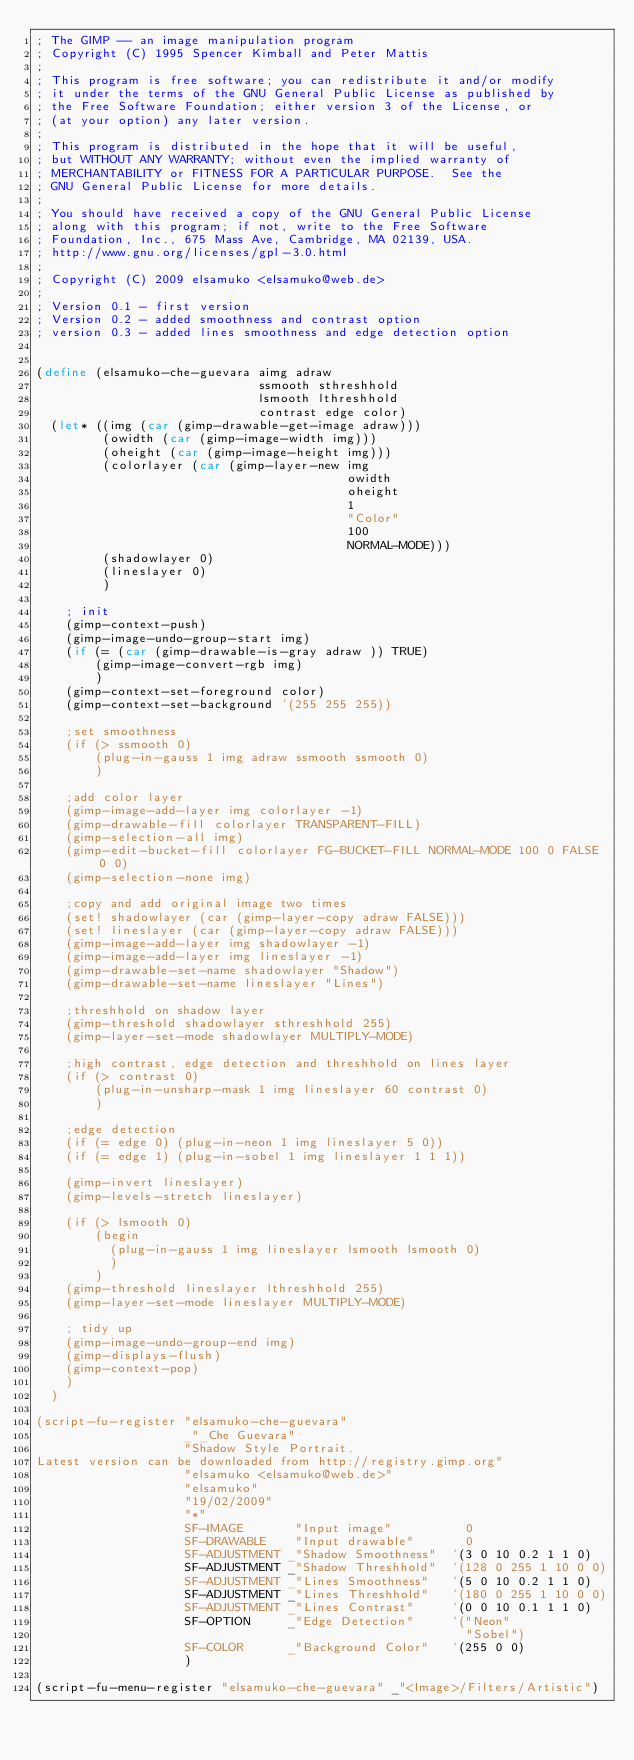<code> <loc_0><loc_0><loc_500><loc_500><_Scheme_>; The GIMP -- an image manipulation program
; Copyright (C) 1995 Spencer Kimball and Peter Mattis
;
; This program is free software; you can redistribute it and/or modify
; it under the terms of the GNU General Public License as published by
; the Free Software Foundation; either version 3 of the License, or
; (at your option) any later version.
; 
; This program is distributed in the hope that it will be useful,
; but WITHOUT ANY WARRANTY; without even the implied warranty of
; MERCHANTABILITY or FITNESS FOR A PARTICULAR PURPOSE.  See the
; GNU General Public License for more details.
; 
; You should have received a copy of the GNU General Public License
; along with this program; if not, write to the Free Software
; Foundation, Inc., 675 Mass Ave, Cambridge, MA 02139, USA.
; http://www.gnu.org/licenses/gpl-3.0.html
;
; Copyright (C) 2009 elsamuko <elsamuko@web.de>
;
; Version 0.1 - first version
; Version 0.2 - added smoothness and contrast option
; version 0.3 - added lines smoothness and edge detection option


(define (elsamuko-che-guevara aimg adraw
                              ssmooth sthreshhold
                              lsmooth lthreshhold
                              contrast edge color)
  (let* ((img (car (gimp-drawable-get-image adraw)))
         (owidth (car (gimp-image-width img)))
         (oheight (car (gimp-image-height img)))
         (colorlayer (car (gimp-layer-new img
                                          owidth 
                                          oheight
                                          1
                                          "Color" 
                                          100 
                                          NORMAL-MODE)))
         (shadowlayer 0)
         (lineslayer 0)
         )
    
    ; init
    (gimp-context-push)
    (gimp-image-undo-group-start img)
    (if (= (car (gimp-drawable-is-gray adraw )) TRUE)
        (gimp-image-convert-rgb img)
        )
    (gimp-context-set-foreground color)
    (gimp-context-set-background '(255 255 255))
    
    ;set smoothness
    (if (> ssmooth 0)
        (plug-in-gauss 1 img adraw ssmooth ssmooth 0)
        )
    
    ;add color layer
    (gimp-image-add-layer img colorlayer -1)
    (gimp-drawable-fill colorlayer TRANSPARENT-FILL)
    (gimp-selection-all img)
    (gimp-edit-bucket-fill colorlayer FG-BUCKET-FILL NORMAL-MODE 100 0 FALSE 0 0)
    (gimp-selection-none img)
    
    ;copy and add original image two times
    (set! shadowlayer (car (gimp-layer-copy adraw FALSE)))
    (set! lineslayer (car (gimp-layer-copy adraw FALSE)))
    (gimp-image-add-layer img shadowlayer -1)
    (gimp-image-add-layer img lineslayer -1)
    (gimp-drawable-set-name shadowlayer "Shadow")
    (gimp-drawable-set-name lineslayer "Lines")
    
    ;threshhold on shadow layer
    (gimp-threshold shadowlayer sthreshhold 255)
    (gimp-layer-set-mode shadowlayer MULTIPLY-MODE)
    
    ;high contrast, edge detection and threshhold on lines layer
    (if (> contrast 0)
        (plug-in-unsharp-mask 1 img lineslayer 60 contrast 0)
        )
    
    ;edge detection
    (if (= edge 0) (plug-in-neon 1 img lineslayer 5 0))
    (if (= edge 1) (plug-in-sobel 1 img lineslayer 1 1 1))

    (gimp-invert lineslayer)
    (gimp-levels-stretch lineslayer)
    
    (if (> lsmooth 0)
        (begin
          (plug-in-gauss 1 img lineslayer lsmooth lsmooth 0)
          )
        )
    (gimp-threshold lineslayer lthreshhold 255)
    (gimp-layer-set-mode lineslayer MULTIPLY-MODE)
    
    ; tidy up
    (gimp-image-undo-group-end img)
    (gimp-displays-flush)
    (gimp-context-pop)
    )
  )

(script-fu-register "elsamuko-che-guevara"
                    _"_Che Guevara"
                    "Shadow Style Portrait.
Latest version can be downloaded from http://registry.gimp.org"
                    "elsamuko <elsamuko@web.de>"
                    "elsamuko"
                    "19/02/2009"
                    "*"
                    SF-IMAGE       "Input image"          0
                    SF-DRAWABLE    "Input drawable"       0
                    SF-ADJUSTMENT _"Shadow Smoothness"  '(3 0 10 0.2 1 1 0)
                    SF-ADJUSTMENT _"Shadow Threshhold"  '(128 0 255 1 10 0 0)
                    SF-ADJUSTMENT _"Lines Smoothness"   '(5 0 10 0.2 1 1 0)
                    SF-ADJUSTMENT _"Lines Threshhold"   '(180 0 255 1 10 0 0)
                    SF-ADJUSTMENT _"Lines Contrast"     '(0 0 10 0.1 1 1 0)
                    SF-OPTION     _"Edge Detection"     '("Neon"
                                                          "Sobel")
                    SF-COLOR      _"Background Color"   '(255 0 0)
                    )

(script-fu-menu-register "elsamuko-che-guevara" _"<Image>/Filters/Artistic")
</code> 